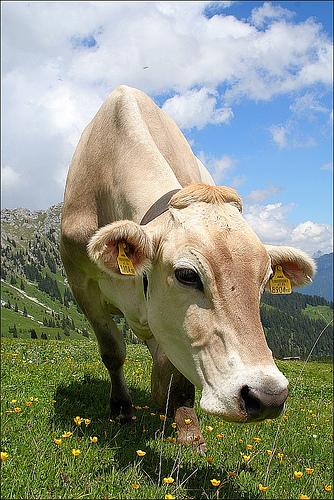What type of animal is this?
Concise answer only. Cow. Does the cow have a tag on it's ear?
Quick response, please. Yes. What color is the cow?
Quick response, please. Brown. 